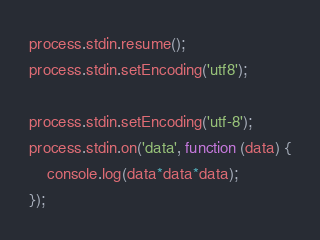Convert code to text. <code><loc_0><loc_0><loc_500><loc_500><_JavaScript_>process.stdin.resume();
process.stdin.setEncoding('utf8');

process.stdin.setEncoding('utf-8');
process.stdin.on('data', function (data) {
    console.log(data*data*data);
});</code> 